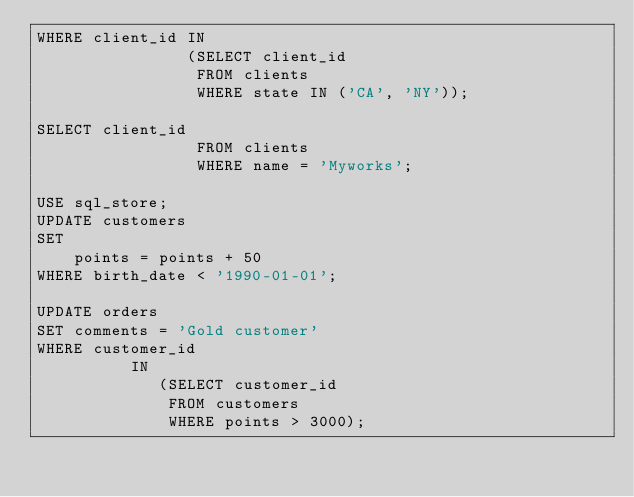<code> <loc_0><loc_0><loc_500><loc_500><_SQL_>WHERE client_id IN
                (SELECT client_id
                 FROM clients
                 WHERE state IN ('CA', 'NY'));

SELECT client_id
                 FROM clients
                 WHERE name = 'Myworks';

USE sql_store;
UPDATE customers
SET
    points = points + 50
WHERE birth_date < '1990-01-01';

UPDATE orders
SET comments = 'Gold customer'
WHERE customer_id
          IN
             (SELECT customer_id
              FROM customers
              WHERE points > 3000);
</code> 